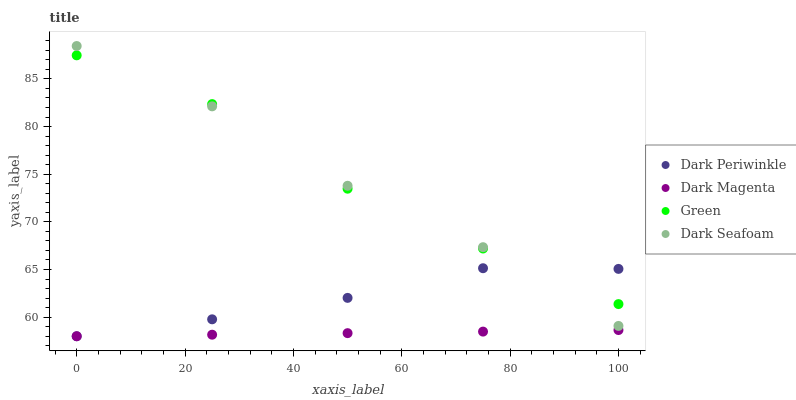Does Dark Magenta have the minimum area under the curve?
Answer yes or no. Yes. Does Green have the maximum area under the curve?
Answer yes or no. Yes. Does Dark Periwinkle have the minimum area under the curve?
Answer yes or no. No. Does Dark Periwinkle have the maximum area under the curve?
Answer yes or no. No. Is Dark Magenta the smoothest?
Answer yes or no. Yes. Is Green the roughest?
Answer yes or no. Yes. Is Dark Periwinkle the smoothest?
Answer yes or no. No. Is Dark Periwinkle the roughest?
Answer yes or no. No. Does Dark Periwinkle have the lowest value?
Answer yes or no. Yes. Does Green have the lowest value?
Answer yes or no. No. Does Dark Seafoam have the highest value?
Answer yes or no. Yes. Does Green have the highest value?
Answer yes or no. No. Is Dark Magenta less than Dark Seafoam?
Answer yes or no. Yes. Is Green greater than Dark Magenta?
Answer yes or no. Yes. Does Dark Periwinkle intersect Green?
Answer yes or no. Yes. Is Dark Periwinkle less than Green?
Answer yes or no. No. Is Dark Periwinkle greater than Green?
Answer yes or no. No. Does Dark Magenta intersect Dark Seafoam?
Answer yes or no. No. 